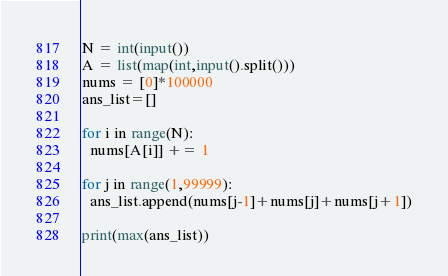<code> <loc_0><loc_0><loc_500><loc_500><_Python_>N = int(input())
A = list(map(int,input().split()))
nums = [0]*100000
ans_list=[]

for i in range(N):
  nums[A[i]] += 1

for j in range(1,99999):
  ans_list.append(nums[j-1]+nums[j]+nums[j+1])

print(max(ans_list))</code> 